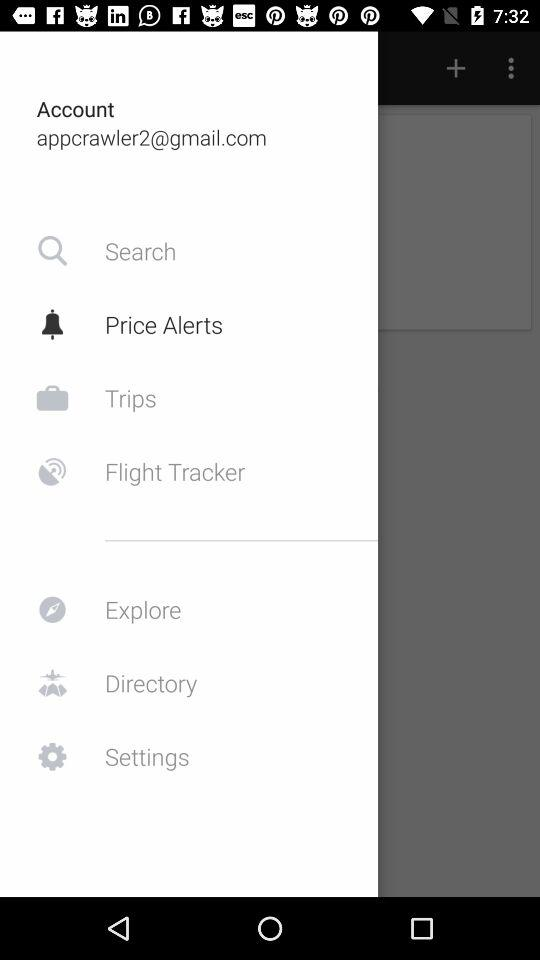What is the email address? The email address is appcrawler2@gmail.com. 